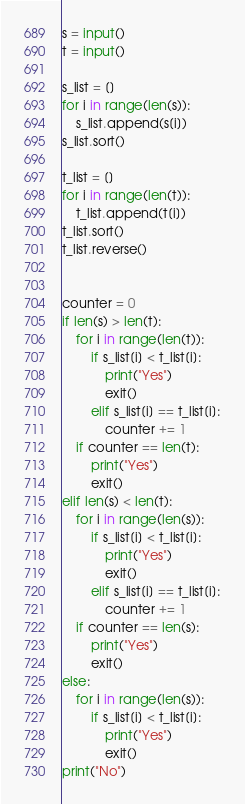Convert code to text. <code><loc_0><loc_0><loc_500><loc_500><_Python_>s = input()
t = input()

s_list = []
for i in range(len(s)):
    s_list.append(s[i])
s_list.sort()

t_list = []
for i in range(len(t)):
    t_list.append(t[i])
t_list.sort()
t_list.reverse()


counter = 0
if len(s) > len(t):
    for i in range(len(t)):
        if s_list[i] < t_list[i]:
            print("Yes")
            exit()
        elif s_list[i] == t_list[i]:
            counter += 1
    if counter == len(t):
        print("Yes")
        exit()
elif len(s) < len(t):
    for i in range(len(s)):
        if s_list[i] < t_list[i]:
            print("Yes")
            exit()
        elif s_list[i] == t_list[i]:
            counter += 1
    if counter == len(s):
        print("Yes")
        exit()
else:
    for i in range(len(s)):
        if s_list[i] < t_list[i]:
            print("Yes")
            exit()
print("No")</code> 